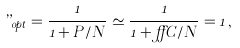<formula> <loc_0><loc_0><loc_500><loc_500>\varepsilon _ { o p t } = \frac { 1 } { 1 + P / N } \simeq \frac { 1 } { 1 + \alpha C / N } = 1 \, ,</formula> 